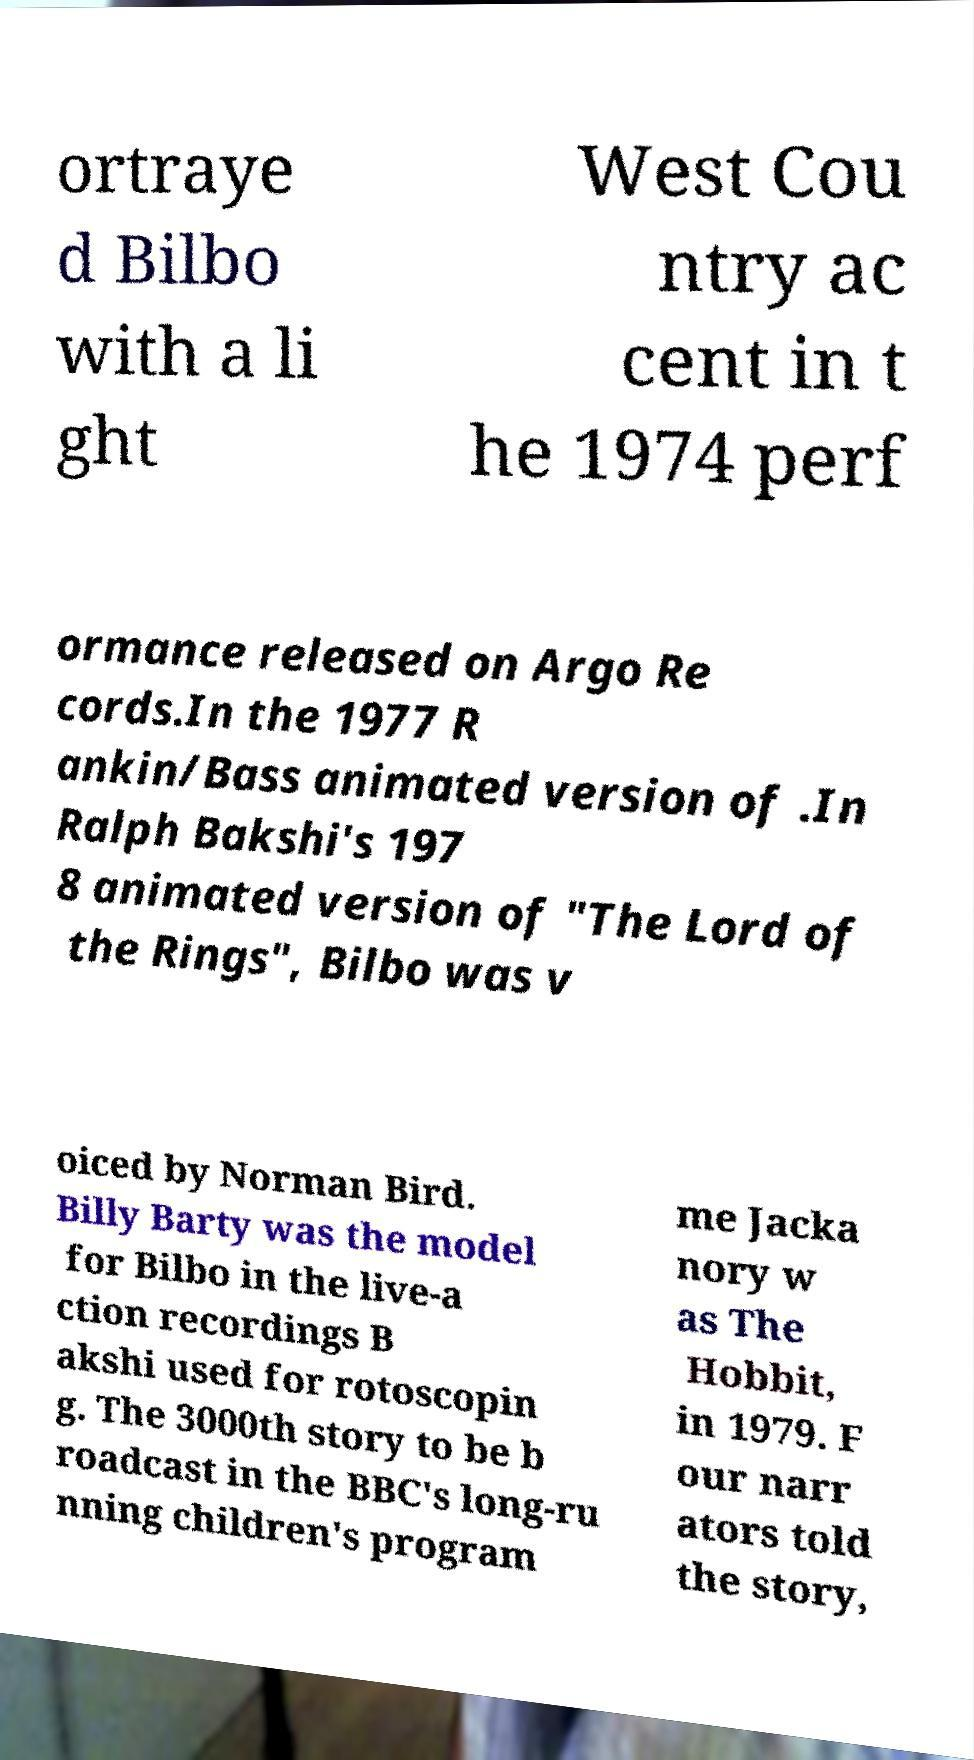Can you accurately transcribe the text from the provided image for me? ortraye d Bilbo with a li ght West Cou ntry ac cent in t he 1974 perf ormance released on Argo Re cords.In the 1977 R ankin/Bass animated version of .In Ralph Bakshi's 197 8 animated version of "The Lord of the Rings", Bilbo was v oiced by Norman Bird. Billy Barty was the model for Bilbo in the live-a ction recordings B akshi used for rotoscopin g. The 3000th story to be b roadcast in the BBC's long-ru nning children's program me Jacka nory w as The Hobbit, in 1979. F our narr ators told the story, 